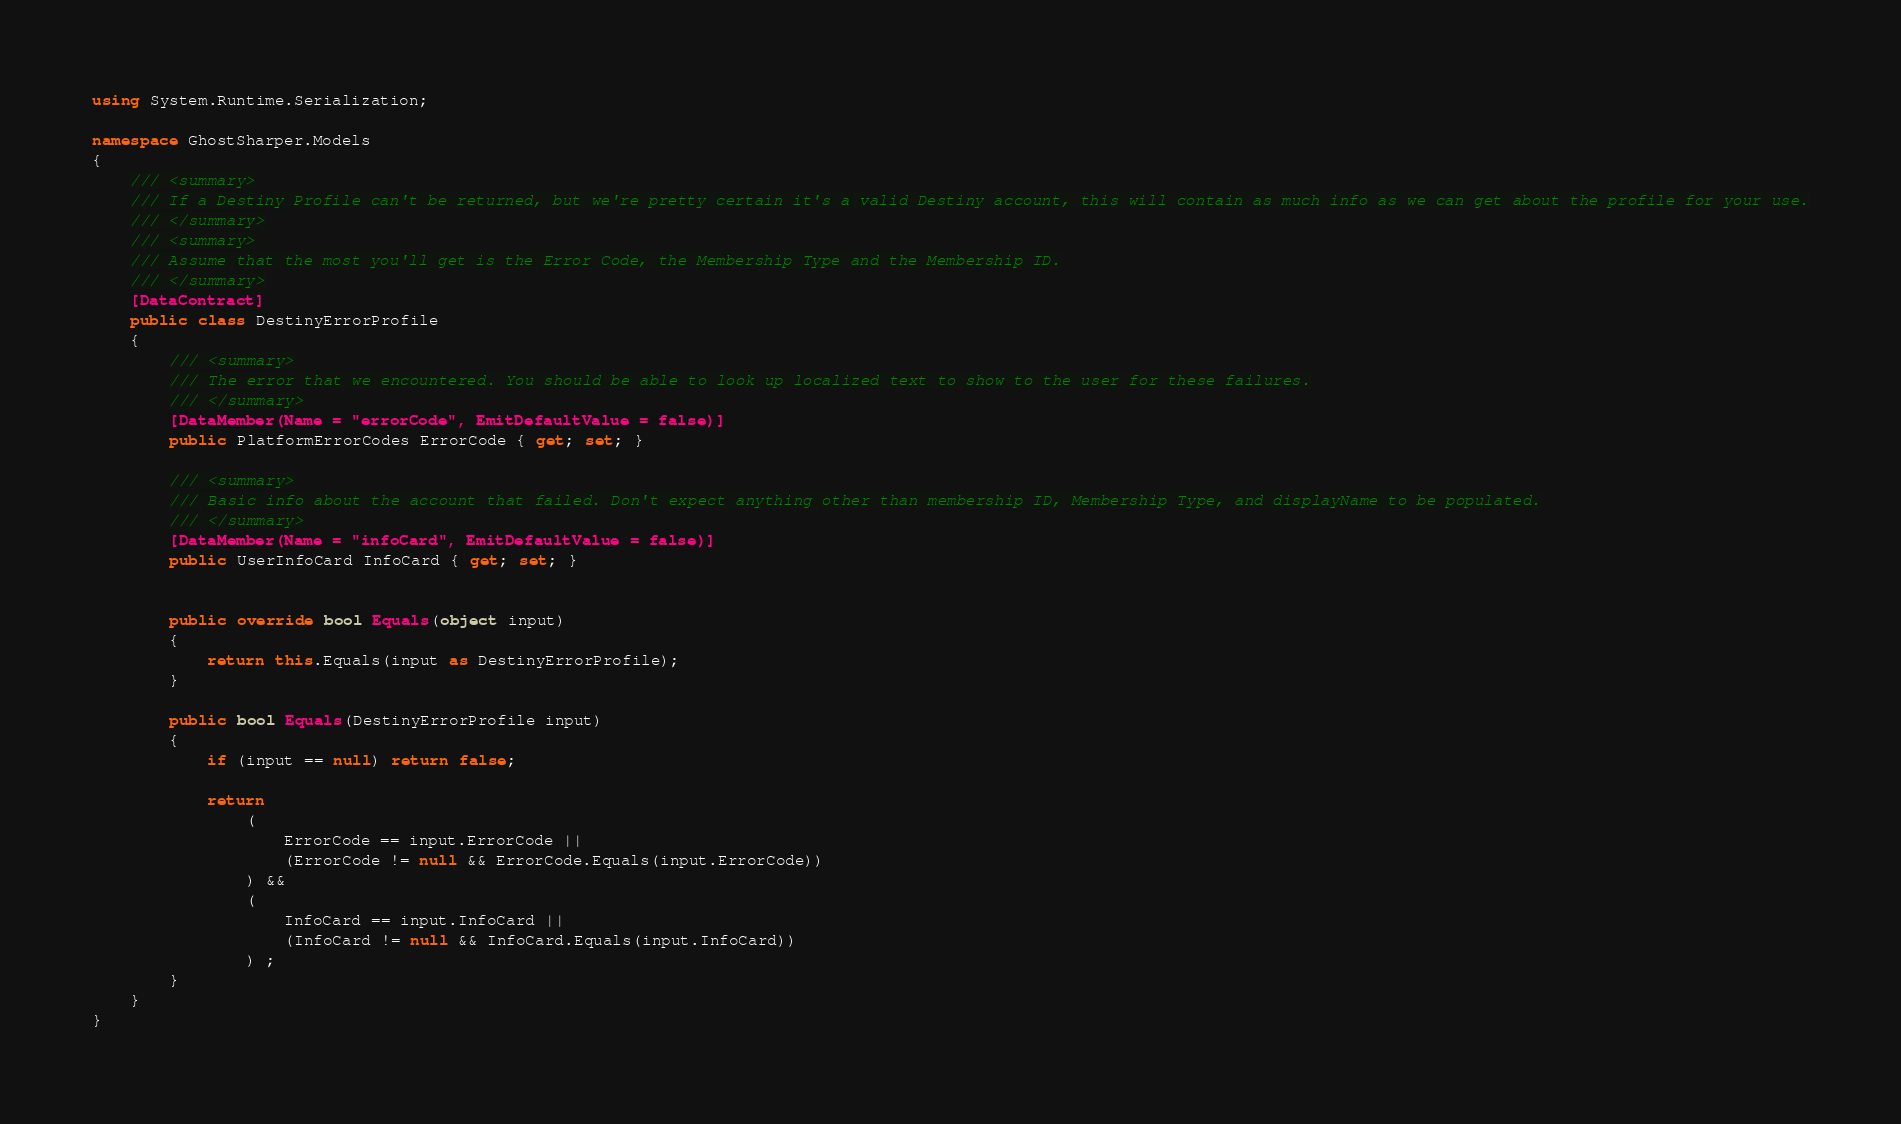<code> <loc_0><loc_0><loc_500><loc_500><_C#_>using System.Runtime.Serialization;

namespace GhostSharper.Models
{
    /// <summary>
    /// If a Destiny Profile can't be returned, but we're pretty certain it's a valid Destiny account, this will contain as much info as we can get about the profile for your use.
    /// </summary>
    /// <summary>
    /// Assume that the most you'll get is the Error Code, the Membership Type and the Membership ID.
    /// </summary>
    [DataContract]
    public class DestinyErrorProfile
    {
        /// <summary>
        /// The error that we encountered. You should be able to look up localized text to show to the user for these failures.
        /// </summary>
        [DataMember(Name = "errorCode", EmitDefaultValue = false)]
        public PlatformErrorCodes ErrorCode { get; set; }

        /// <summary>
        /// Basic info about the account that failed. Don't expect anything other than membership ID, Membership Type, and displayName to be populated.
        /// </summary>
        [DataMember(Name = "infoCard", EmitDefaultValue = false)]
        public UserInfoCard InfoCard { get; set; }


        public override bool Equals(object input)
        {
            return this.Equals(input as DestinyErrorProfile);
        }

        public bool Equals(DestinyErrorProfile input)
        {
            if (input == null) return false;

            return
                (
                    ErrorCode == input.ErrorCode ||
                    (ErrorCode != null && ErrorCode.Equals(input.ErrorCode))
                ) &&
                (
                    InfoCard == input.InfoCard ||
                    (InfoCard != null && InfoCard.Equals(input.InfoCard))
                ) ;
        }
    }
}

</code> 